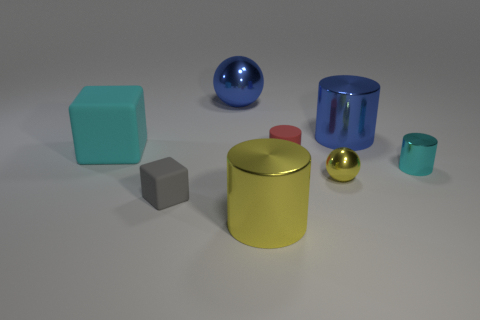There is a big thing that is the same color as the tiny metal cylinder; what is it made of?
Make the answer very short. Rubber. How many other objects are there of the same material as the red cylinder?
Provide a short and direct response. 2. There is a matte object that is to the left of the red thing and on the right side of the big matte cube; what shape is it?
Your answer should be very brief. Cube. What is the color of the big object that is the same material as the small red object?
Make the answer very short. Cyan. Is the number of gray objects on the right side of the cyan shiny cylinder the same as the number of green balls?
Provide a short and direct response. Yes. What is the shape of the red thing that is the same size as the cyan shiny cylinder?
Give a very brief answer. Cylinder. What number of other things are there of the same shape as the small cyan object?
Give a very brief answer. 3. There is a yellow cylinder; does it have the same size as the blue thing that is behind the big blue metallic cylinder?
Your response must be concise. Yes. How many objects are either large shiny cylinders that are behind the large cyan rubber thing or big cyan matte things?
Offer a terse response. 2. There is a matte thing right of the gray block; what shape is it?
Offer a very short reply. Cylinder. 